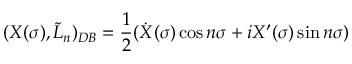<formula> <loc_0><loc_0><loc_500><loc_500>( X ( \sigma ) , \tilde { L } _ { n } ) _ { D B } = \frac { 1 } { 2 } ( \dot { X } ( \sigma ) \cos n \sigma + i X ^ { \prime } ( \sigma ) \sin n \sigma )</formula> 